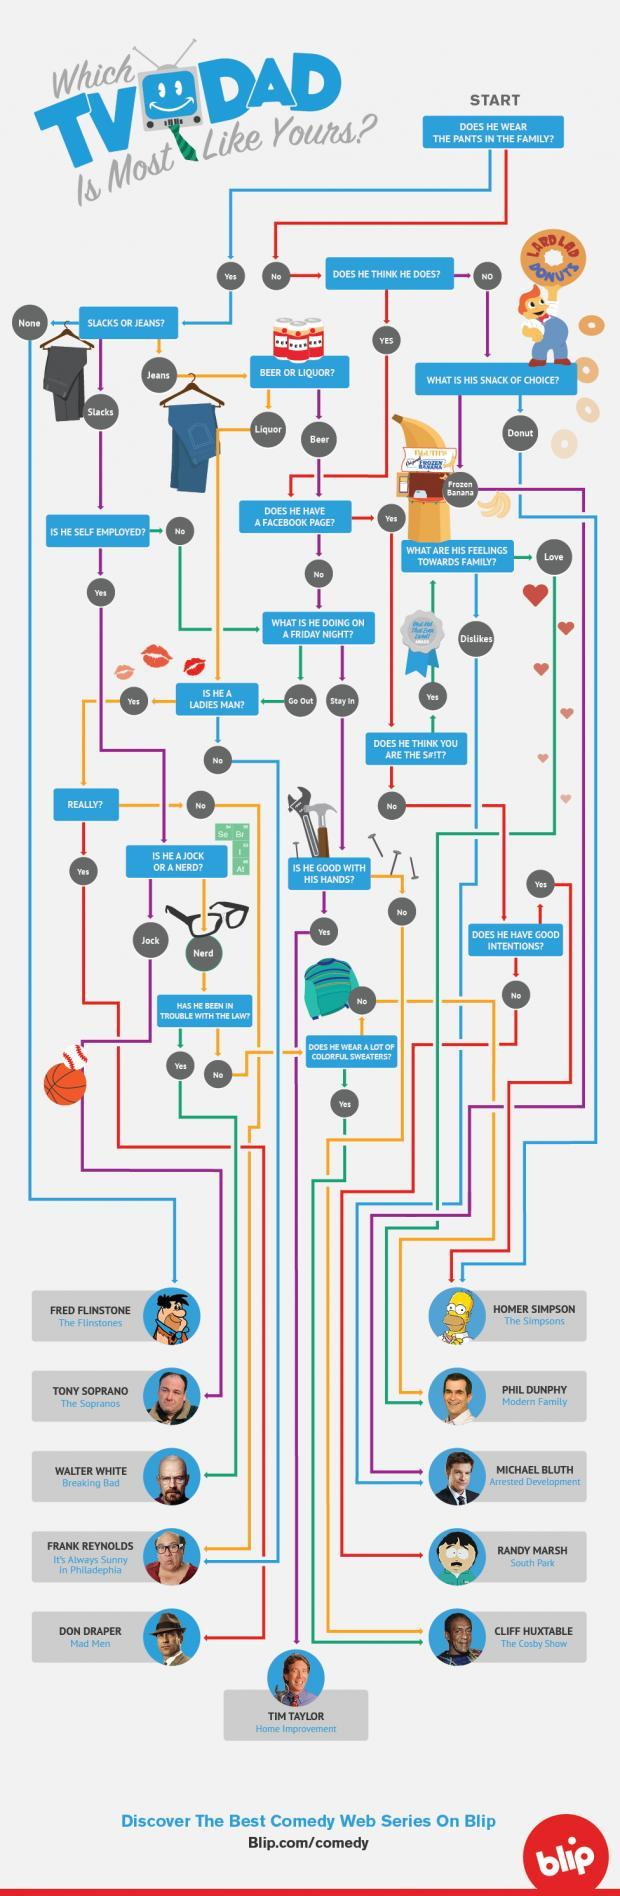What is the colour of the sweater icon shown - green or red?
Answer the question with a short phrase. green 